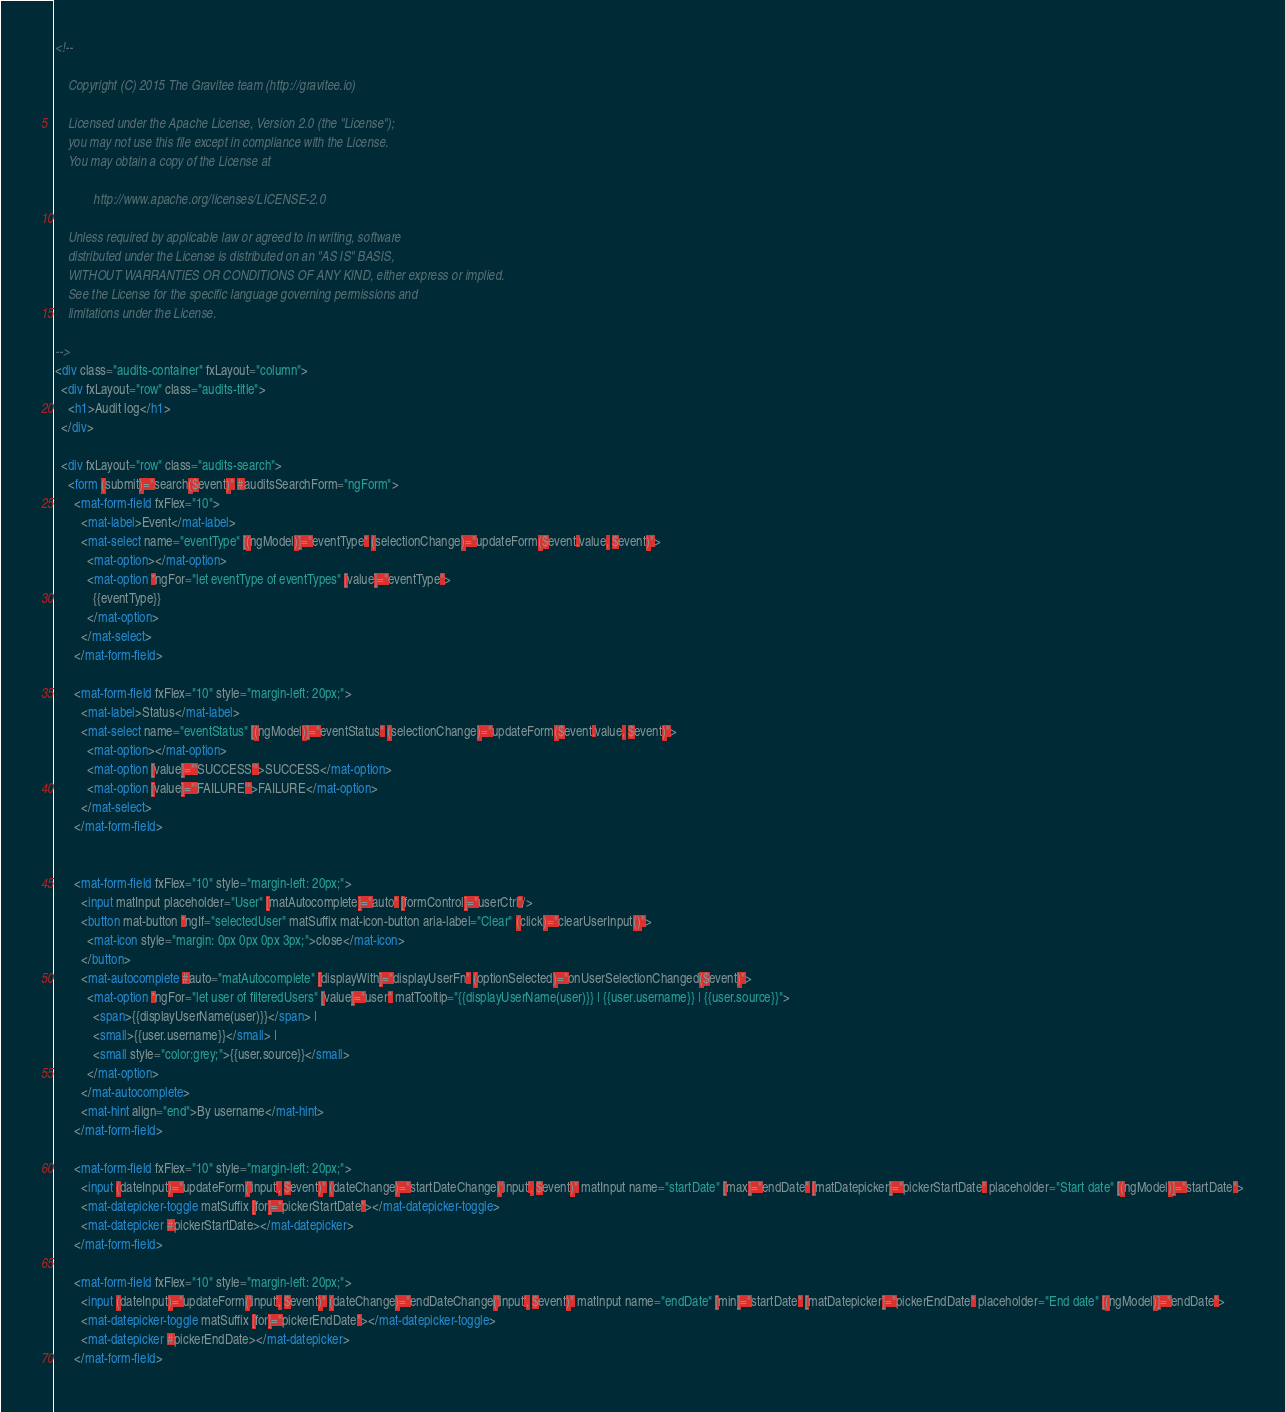Convert code to text. <code><loc_0><loc_0><loc_500><loc_500><_HTML_><!--

    Copyright (C) 2015 The Gravitee team (http://gravitee.io)

    Licensed under the Apache License, Version 2.0 (the "License");
    you may not use this file except in compliance with the License.
    You may obtain a copy of the License at

            http://www.apache.org/licenses/LICENSE-2.0

    Unless required by applicable law or agreed to in writing, software
    distributed under the License is distributed on an "AS IS" BASIS,
    WITHOUT WARRANTIES OR CONDITIONS OF ANY KIND, either express or implied.
    See the License for the specific language governing permissions and
    limitations under the License.

-->
<div class="audits-container" fxLayout="column">
  <div fxLayout="row" class="audits-title">
    <h1>Audit log</h1>
  </div>

  <div fxLayout="row" class="audits-search">
    <form (submit)="search($event)" #auditsSearchForm="ngForm">
      <mat-form-field fxFlex="10">
        <mat-label>Event</mat-label>
        <mat-select name="eventType" [(ngModel)]="eventType" (selectionChange)="updateForm($event.value, $event)">
          <mat-option></mat-option>
          <mat-option *ngFor="let eventType of eventTypes" [value]="eventType">
            {{eventType}}
          </mat-option>
        </mat-select>
      </mat-form-field>

      <mat-form-field fxFlex="10" style="margin-left: 20px;">
        <mat-label>Status</mat-label>
        <mat-select name="eventStatus" [(ngModel)]="eventStatus" (selectionChange)="updateForm($event.value, $event)">
          <mat-option></mat-option>
          <mat-option [value]="'SUCCESS'">SUCCESS</mat-option>
          <mat-option [value]="'FAILURE'">FAILURE</mat-option>
        </mat-select>
      </mat-form-field>


      <mat-form-field fxFlex="10" style="margin-left: 20px;">
        <input matInput placeholder="User" [matAutocomplete]="auto" [formControl]="userCtrl"/>
        <button mat-button *ngIf="selectedUser" matSuffix mat-icon-button aria-label="Clear" (click)="clearUserInput()">
          <mat-icon style="margin: 0px 0px 0px 3px;">close</mat-icon>
        </button>
        <mat-autocomplete #auto="matAutocomplete" [displayWith]="displayUserFn" (optionSelected)="onUserSelectionChanged($event)">
          <mat-option *ngFor="let user of filteredUsers" [value]="user" matTooltip="{{displayUserName(user)}} | {{user.username}} | {{user.source}}">
            <span>{{displayUserName(user)}}</span> |
            <small>{{user.username}}</small> |
            <small style="color:grey;">{{user.source}}</small>
          </mat-option>
        </mat-autocomplete>
        <mat-hint align="end">By username</mat-hint>
      </mat-form-field>

      <mat-form-field fxFlex="10" style="margin-left: 20px;">
        <input (dateInput)="updateForm('input', $event)" (dateChange)="startDateChange('input', $event)" matInput name="startDate" [max]="endDate" [matDatepicker]="pickerStartDate" placeholder="Start date" [(ngModel)]="startDate">
        <mat-datepicker-toggle matSuffix [for]="pickerStartDate"></mat-datepicker-toggle>
        <mat-datepicker #pickerStartDate></mat-datepicker>
      </mat-form-field>

      <mat-form-field fxFlex="10" style="margin-left: 20px;">
        <input (dateInput)="updateForm('input', $event)" (dateChange)="endDateChange('input', $event)" matInput name="endDate" [min]="startDate" [matDatepicker]="pickerEndDate" placeholder="End date" [(ngModel)]="endDate">
        <mat-datepicker-toggle matSuffix [for]="pickerEndDate"></mat-datepicker-toggle>
        <mat-datepicker #pickerEndDate></mat-datepicker>
      </mat-form-field>
</code> 